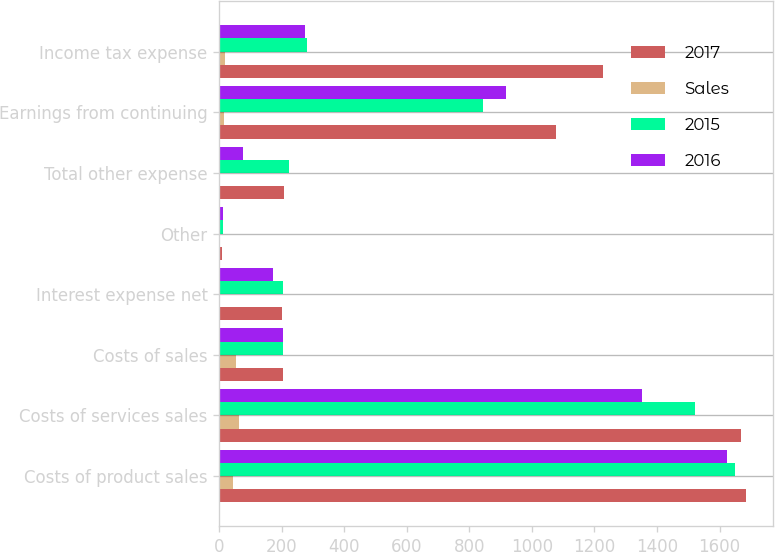<chart> <loc_0><loc_0><loc_500><loc_500><stacked_bar_chart><ecel><fcel>Costs of product sales<fcel>Costs of services sales<fcel>Costs of sales<fcel>Interest expense net<fcel>Other<fcel>Total other expense<fcel>Earnings from continuing<fcel>Income tax expense<nl><fcel>2017<fcel>1686<fcel>1670<fcel>205<fcel>201<fcel>8<fcel>206<fcel>1076<fcel>1227<nl><fcel>Sales<fcel>44.7<fcel>64<fcel>52.6<fcel>3.2<fcel>0.1<fcel>3.2<fcel>16.9<fcel>19.2<nl><fcel>2015<fcel>1649<fcel>1520<fcel>205<fcel>205<fcel>12<fcel>223<fcel>844<fcel>282<nl><fcel>2016<fcel>1625<fcel>1351<fcel>205<fcel>173<fcel>11<fcel>77<fcel>917<fcel>274<nl></chart> 